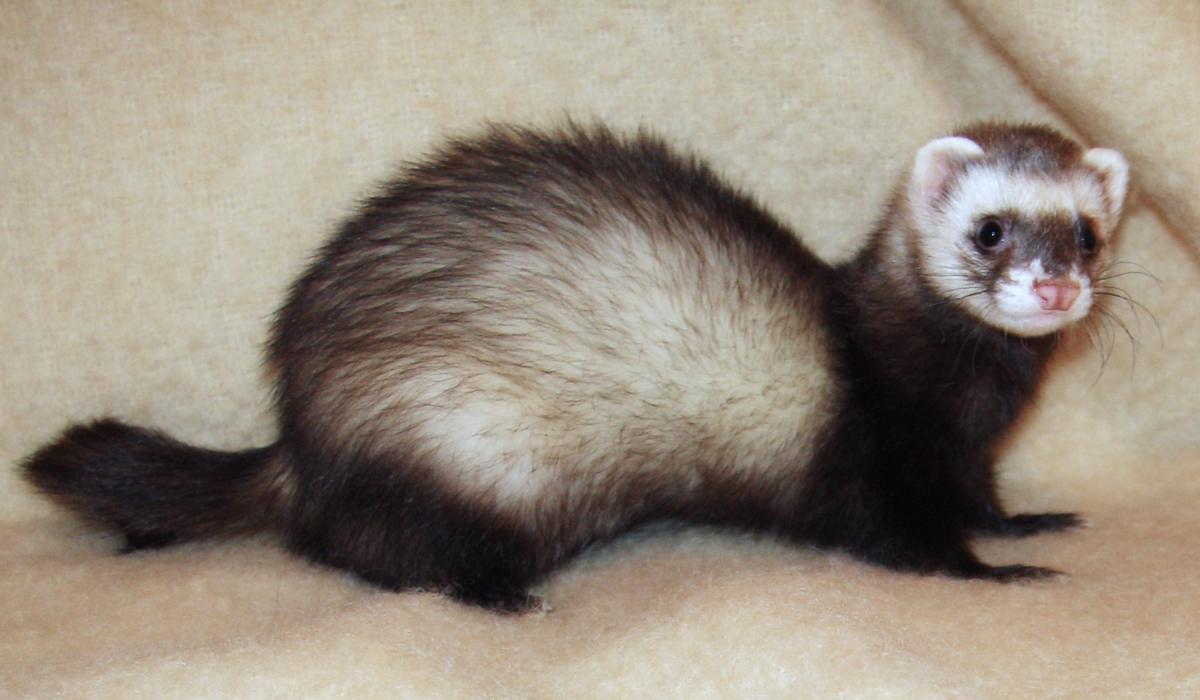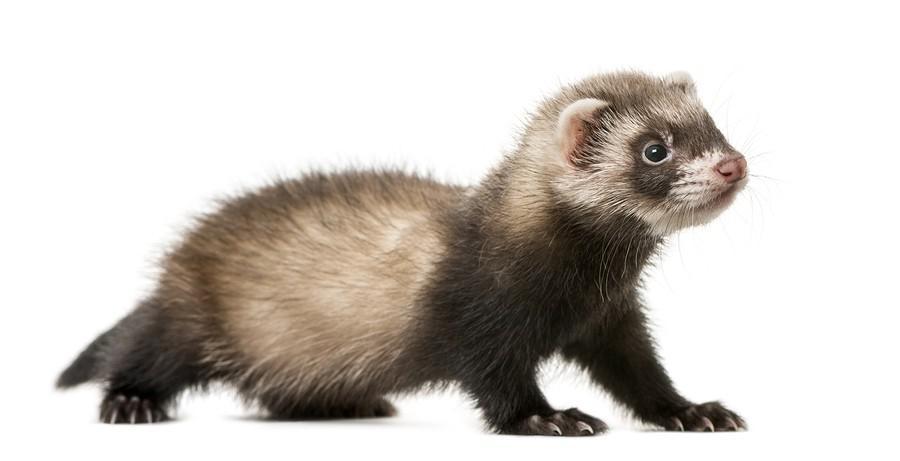The first image is the image on the left, the second image is the image on the right. Evaluate the accuracy of this statement regarding the images: "All of the ferrets are visible as a full body shot.". Is it true? Answer yes or no. Yes. 